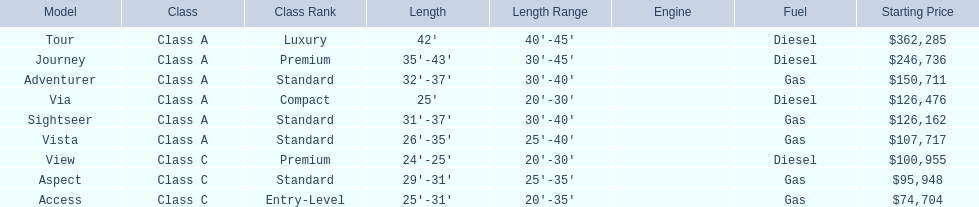What is the highest price of a winnebago model? $362,285. What is the name of the vehicle with this price? Tour. 